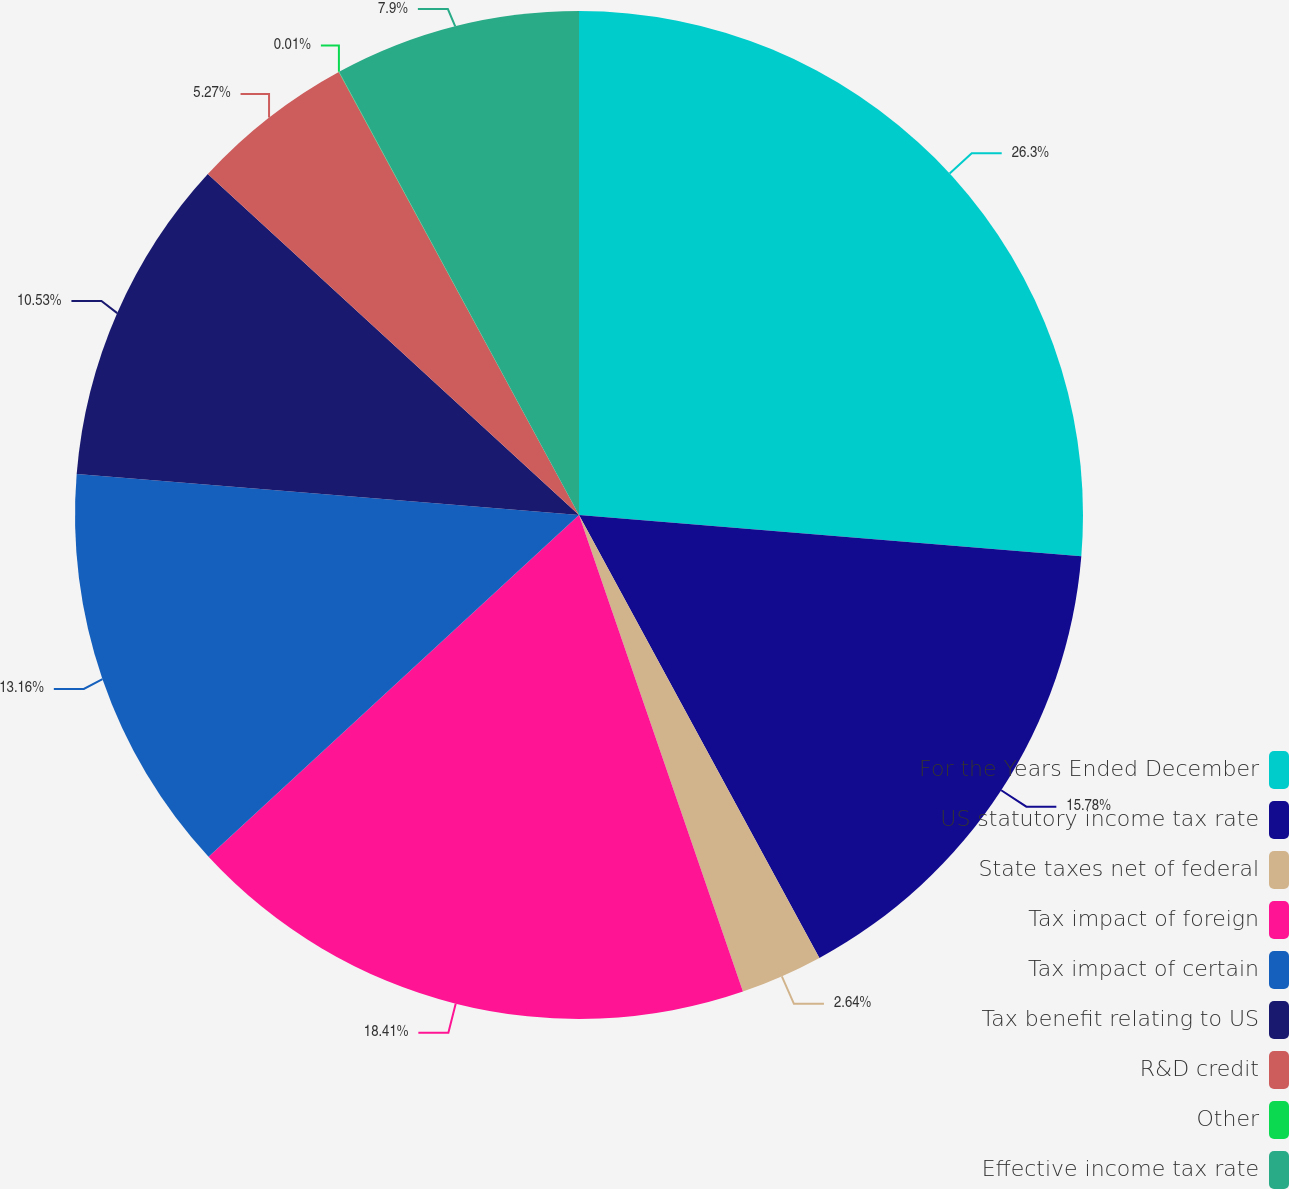Convert chart to OTSL. <chart><loc_0><loc_0><loc_500><loc_500><pie_chart><fcel>For the Years Ended December<fcel>US statutory income tax rate<fcel>State taxes net of federal<fcel>Tax impact of foreign<fcel>Tax impact of certain<fcel>Tax benefit relating to US<fcel>R&D credit<fcel>Other<fcel>Effective income tax rate<nl><fcel>26.31%<fcel>15.79%<fcel>2.64%<fcel>18.42%<fcel>13.16%<fcel>10.53%<fcel>5.27%<fcel>0.01%<fcel>7.9%<nl></chart> 